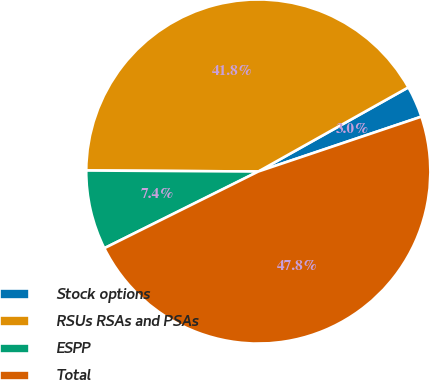Convert chart. <chart><loc_0><loc_0><loc_500><loc_500><pie_chart><fcel>Stock options<fcel>RSUs RSAs and PSAs<fcel>ESPP<fcel>Total<nl><fcel>2.97%<fcel>41.77%<fcel>7.45%<fcel>47.81%<nl></chart> 